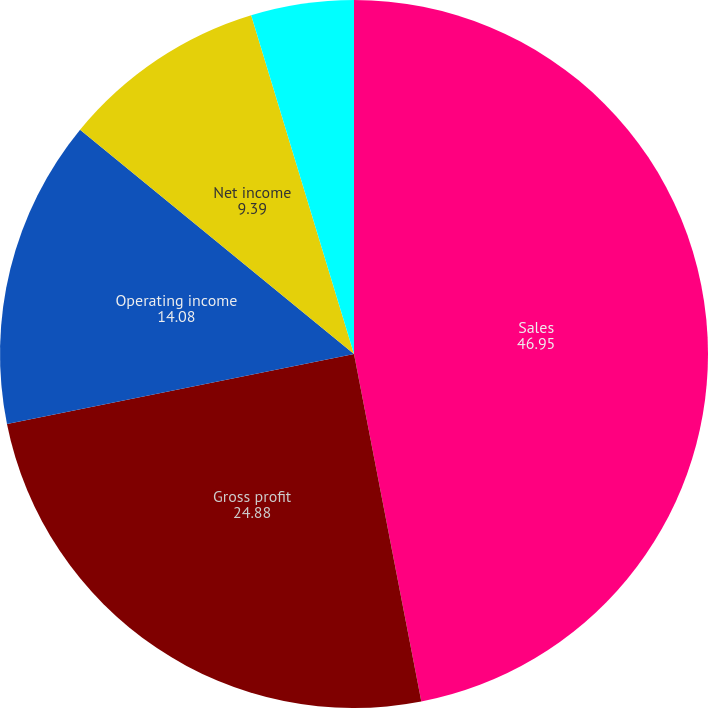Convert chart to OTSL. <chart><loc_0><loc_0><loc_500><loc_500><pie_chart><fcel>Sales<fcel>Gross profit<fcel>Operating income<fcel>Net income<fcel>Earnings per share - basic (1)<fcel>Earnings per share - assuming<nl><fcel>46.95%<fcel>24.88%<fcel>14.08%<fcel>9.39%<fcel>4.69%<fcel>0.0%<nl></chart> 